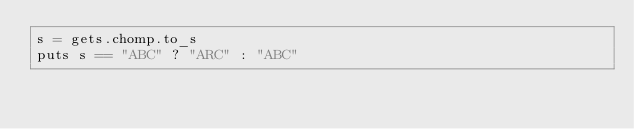Convert code to text. <code><loc_0><loc_0><loc_500><loc_500><_Ruby_>s = gets.chomp.to_s
puts s == "ABC" ? "ARC" : "ABC"</code> 